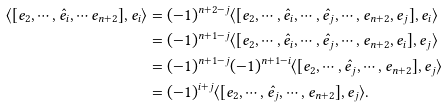<formula> <loc_0><loc_0><loc_500><loc_500>\langle [ e _ { 2 } , \cdots , \hat { e _ { i } } , \cdots e _ { n + 2 } ] , e _ { i } \rangle & = ( - 1 ) ^ { n + 2 - j } \langle [ e _ { 2 } , \cdots , \hat { e _ { i } } , \cdots , \hat { e _ { j } } , \cdots , e _ { n + 2 } , e _ { j } ] , e _ { i } \rangle \\ & = ( - 1 ) ^ { n + 1 - j } \langle [ e _ { 2 } , \cdots , \hat { e _ { i } } , \cdots , \hat { e _ { j } } , \cdots , e _ { n + 2 } , e _ { i } ] , e _ { j } \rangle \\ & = ( - 1 ) ^ { n + 1 - j } ( - 1 ) ^ { n + 1 - i } \langle [ e _ { 2 } , \cdots , \hat { e _ { j } } , \cdots , e _ { n + 2 } ] , e _ { j } \rangle \\ & = ( - 1 ) ^ { i + j } \langle [ e _ { 2 } , \cdots , \hat { e _ { j } } , \cdots , e _ { n + 2 } ] , e _ { j } \rangle .</formula> 